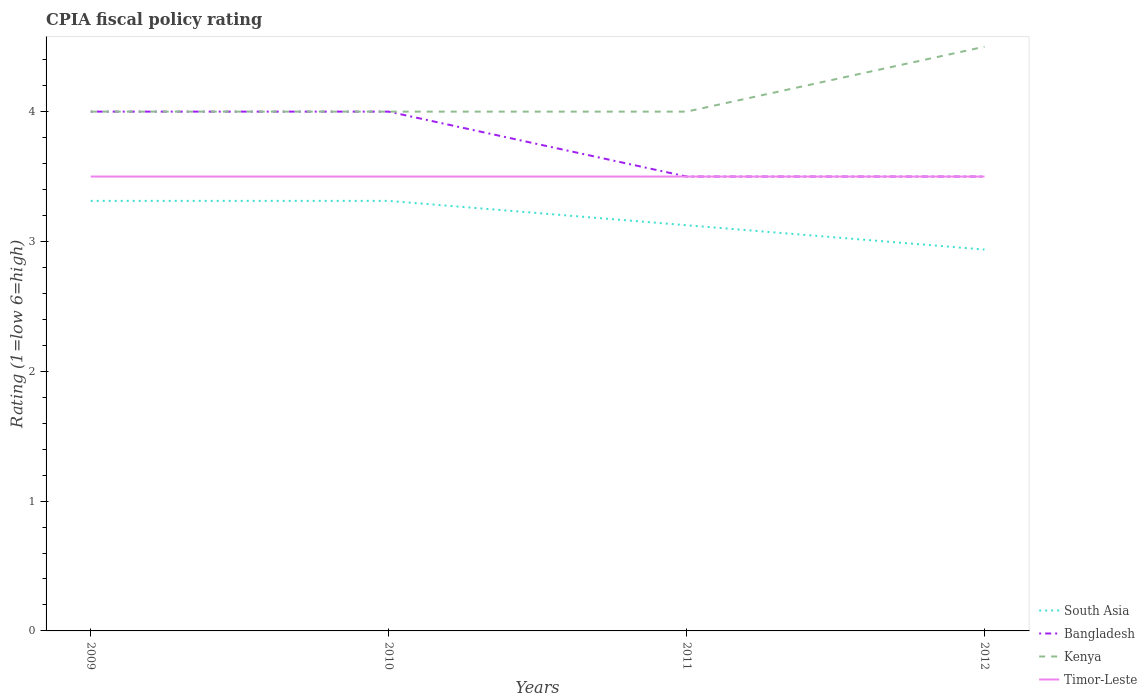Does the line corresponding to Bangladesh intersect with the line corresponding to Timor-Leste?
Provide a succinct answer. Yes. Across all years, what is the maximum CPIA rating in Bangladesh?
Offer a terse response. 3.5. What is the difference between the highest and the second highest CPIA rating in Timor-Leste?
Your response must be concise. 0. What is the difference between the highest and the lowest CPIA rating in Kenya?
Offer a very short reply. 1. What is the difference between two consecutive major ticks on the Y-axis?
Offer a very short reply. 1. Are the values on the major ticks of Y-axis written in scientific E-notation?
Provide a short and direct response. No. Does the graph contain grids?
Your response must be concise. No. How many legend labels are there?
Your answer should be very brief. 4. What is the title of the graph?
Provide a short and direct response. CPIA fiscal policy rating. What is the label or title of the X-axis?
Your answer should be very brief. Years. What is the label or title of the Y-axis?
Keep it short and to the point. Rating (1=low 6=high). What is the Rating (1=low 6=high) of South Asia in 2009?
Keep it short and to the point. 3.31. What is the Rating (1=low 6=high) of Bangladesh in 2009?
Keep it short and to the point. 4. What is the Rating (1=low 6=high) in South Asia in 2010?
Provide a short and direct response. 3.31. What is the Rating (1=low 6=high) of South Asia in 2011?
Provide a short and direct response. 3.12. What is the Rating (1=low 6=high) of Kenya in 2011?
Provide a short and direct response. 4. What is the Rating (1=low 6=high) in South Asia in 2012?
Make the answer very short. 2.94. What is the Rating (1=low 6=high) of Timor-Leste in 2012?
Provide a short and direct response. 3.5. Across all years, what is the maximum Rating (1=low 6=high) in South Asia?
Offer a terse response. 3.31. Across all years, what is the maximum Rating (1=low 6=high) of Bangladesh?
Keep it short and to the point. 4. Across all years, what is the maximum Rating (1=low 6=high) of Kenya?
Your answer should be very brief. 4.5. Across all years, what is the minimum Rating (1=low 6=high) of South Asia?
Keep it short and to the point. 2.94. Across all years, what is the minimum Rating (1=low 6=high) in Kenya?
Offer a terse response. 4. What is the total Rating (1=low 6=high) in South Asia in the graph?
Keep it short and to the point. 12.69. What is the total Rating (1=low 6=high) of Bangladesh in the graph?
Make the answer very short. 15. What is the total Rating (1=low 6=high) in Kenya in the graph?
Give a very brief answer. 16.5. What is the total Rating (1=low 6=high) of Timor-Leste in the graph?
Offer a very short reply. 14. What is the difference between the Rating (1=low 6=high) of South Asia in 2009 and that in 2010?
Provide a succinct answer. 0. What is the difference between the Rating (1=low 6=high) in Timor-Leste in 2009 and that in 2010?
Offer a terse response. 0. What is the difference between the Rating (1=low 6=high) of South Asia in 2009 and that in 2011?
Your response must be concise. 0.19. What is the difference between the Rating (1=low 6=high) of Timor-Leste in 2009 and that in 2011?
Give a very brief answer. 0. What is the difference between the Rating (1=low 6=high) of Kenya in 2009 and that in 2012?
Your response must be concise. -0.5. What is the difference between the Rating (1=low 6=high) in Timor-Leste in 2009 and that in 2012?
Your response must be concise. 0. What is the difference between the Rating (1=low 6=high) in South Asia in 2010 and that in 2011?
Your answer should be compact. 0.19. What is the difference between the Rating (1=low 6=high) in Kenya in 2010 and that in 2011?
Make the answer very short. 0. What is the difference between the Rating (1=low 6=high) in Timor-Leste in 2010 and that in 2011?
Make the answer very short. 0. What is the difference between the Rating (1=low 6=high) in South Asia in 2010 and that in 2012?
Offer a terse response. 0.38. What is the difference between the Rating (1=low 6=high) in Bangladesh in 2010 and that in 2012?
Offer a very short reply. 0.5. What is the difference between the Rating (1=low 6=high) of Kenya in 2010 and that in 2012?
Offer a terse response. -0.5. What is the difference between the Rating (1=low 6=high) in South Asia in 2011 and that in 2012?
Give a very brief answer. 0.19. What is the difference between the Rating (1=low 6=high) in Kenya in 2011 and that in 2012?
Make the answer very short. -0.5. What is the difference between the Rating (1=low 6=high) of Timor-Leste in 2011 and that in 2012?
Provide a succinct answer. 0. What is the difference between the Rating (1=low 6=high) in South Asia in 2009 and the Rating (1=low 6=high) in Bangladesh in 2010?
Provide a succinct answer. -0.69. What is the difference between the Rating (1=low 6=high) in South Asia in 2009 and the Rating (1=low 6=high) in Kenya in 2010?
Ensure brevity in your answer.  -0.69. What is the difference between the Rating (1=low 6=high) in South Asia in 2009 and the Rating (1=low 6=high) in Timor-Leste in 2010?
Provide a succinct answer. -0.19. What is the difference between the Rating (1=low 6=high) in Kenya in 2009 and the Rating (1=low 6=high) in Timor-Leste in 2010?
Your answer should be very brief. 0.5. What is the difference between the Rating (1=low 6=high) in South Asia in 2009 and the Rating (1=low 6=high) in Bangladesh in 2011?
Your answer should be very brief. -0.19. What is the difference between the Rating (1=low 6=high) of South Asia in 2009 and the Rating (1=low 6=high) of Kenya in 2011?
Offer a terse response. -0.69. What is the difference between the Rating (1=low 6=high) in South Asia in 2009 and the Rating (1=low 6=high) in Timor-Leste in 2011?
Give a very brief answer. -0.19. What is the difference between the Rating (1=low 6=high) in Bangladesh in 2009 and the Rating (1=low 6=high) in Timor-Leste in 2011?
Make the answer very short. 0.5. What is the difference between the Rating (1=low 6=high) in South Asia in 2009 and the Rating (1=low 6=high) in Bangladesh in 2012?
Provide a succinct answer. -0.19. What is the difference between the Rating (1=low 6=high) in South Asia in 2009 and the Rating (1=low 6=high) in Kenya in 2012?
Ensure brevity in your answer.  -1.19. What is the difference between the Rating (1=low 6=high) in South Asia in 2009 and the Rating (1=low 6=high) in Timor-Leste in 2012?
Your answer should be compact. -0.19. What is the difference between the Rating (1=low 6=high) in Bangladesh in 2009 and the Rating (1=low 6=high) in Timor-Leste in 2012?
Make the answer very short. 0.5. What is the difference between the Rating (1=low 6=high) in Kenya in 2009 and the Rating (1=low 6=high) in Timor-Leste in 2012?
Provide a short and direct response. 0.5. What is the difference between the Rating (1=low 6=high) in South Asia in 2010 and the Rating (1=low 6=high) in Bangladesh in 2011?
Offer a terse response. -0.19. What is the difference between the Rating (1=low 6=high) in South Asia in 2010 and the Rating (1=low 6=high) in Kenya in 2011?
Your answer should be compact. -0.69. What is the difference between the Rating (1=low 6=high) in South Asia in 2010 and the Rating (1=low 6=high) in Timor-Leste in 2011?
Your answer should be very brief. -0.19. What is the difference between the Rating (1=low 6=high) of Bangladesh in 2010 and the Rating (1=low 6=high) of Kenya in 2011?
Your answer should be very brief. 0. What is the difference between the Rating (1=low 6=high) in Bangladesh in 2010 and the Rating (1=low 6=high) in Timor-Leste in 2011?
Make the answer very short. 0.5. What is the difference between the Rating (1=low 6=high) in South Asia in 2010 and the Rating (1=low 6=high) in Bangladesh in 2012?
Make the answer very short. -0.19. What is the difference between the Rating (1=low 6=high) of South Asia in 2010 and the Rating (1=low 6=high) of Kenya in 2012?
Provide a short and direct response. -1.19. What is the difference between the Rating (1=low 6=high) in South Asia in 2010 and the Rating (1=low 6=high) in Timor-Leste in 2012?
Provide a short and direct response. -0.19. What is the difference between the Rating (1=low 6=high) in South Asia in 2011 and the Rating (1=low 6=high) in Bangladesh in 2012?
Your answer should be very brief. -0.38. What is the difference between the Rating (1=low 6=high) of South Asia in 2011 and the Rating (1=low 6=high) of Kenya in 2012?
Give a very brief answer. -1.38. What is the difference between the Rating (1=low 6=high) in South Asia in 2011 and the Rating (1=low 6=high) in Timor-Leste in 2012?
Keep it short and to the point. -0.38. What is the difference between the Rating (1=low 6=high) of Bangladesh in 2011 and the Rating (1=low 6=high) of Kenya in 2012?
Ensure brevity in your answer.  -1. What is the difference between the Rating (1=low 6=high) of Kenya in 2011 and the Rating (1=low 6=high) of Timor-Leste in 2012?
Provide a short and direct response. 0.5. What is the average Rating (1=low 6=high) of South Asia per year?
Provide a short and direct response. 3.17. What is the average Rating (1=low 6=high) in Bangladesh per year?
Ensure brevity in your answer.  3.75. What is the average Rating (1=low 6=high) in Kenya per year?
Give a very brief answer. 4.12. In the year 2009, what is the difference between the Rating (1=low 6=high) of South Asia and Rating (1=low 6=high) of Bangladesh?
Give a very brief answer. -0.69. In the year 2009, what is the difference between the Rating (1=low 6=high) of South Asia and Rating (1=low 6=high) of Kenya?
Your response must be concise. -0.69. In the year 2009, what is the difference between the Rating (1=low 6=high) of South Asia and Rating (1=low 6=high) of Timor-Leste?
Make the answer very short. -0.19. In the year 2009, what is the difference between the Rating (1=low 6=high) in Bangladesh and Rating (1=low 6=high) in Timor-Leste?
Your answer should be compact. 0.5. In the year 2010, what is the difference between the Rating (1=low 6=high) in South Asia and Rating (1=low 6=high) in Bangladesh?
Your answer should be very brief. -0.69. In the year 2010, what is the difference between the Rating (1=low 6=high) of South Asia and Rating (1=low 6=high) of Kenya?
Keep it short and to the point. -0.69. In the year 2010, what is the difference between the Rating (1=low 6=high) in South Asia and Rating (1=low 6=high) in Timor-Leste?
Your answer should be very brief. -0.19. In the year 2010, what is the difference between the Rating (1=low 6=high) in Bangladesh and Rating (1=low 6=high) in Timor-Leste?
Ensure brevity in your answer.  0.5. In the year 2010, what is the difference between the Rating (1=low 6=high) in Kenya and Rating (1=low 6=high) in Timor-Leste?
Provide a short and direct response. 0.5. In the year 2011, what is the difference between the Rating (1=low 6=high) of South Asia and Rating (1=low 6=high) of Bangladesh?
Your response must be concise. -0.38. In the year 2011, what is the difference between the Rating (1=low 6=high) in South Asia and Rating (1=low 6=high) in Kenya?
Your answer should be very brief. -0.88. In the year 2011, what is the difference between the Rating (1=low 6=high) in South Asia and Rating (1=low 6=high) in Timor-Leste?
Provide a succinct answer. -0.38. In the year 2011, what is the difference between the Rating (1=low 6=high) of Bangladesh and Rating (1=low 6=high) of Kenya?
Your answer should be compact. -0.5. In the year 2011, what is the difference between the Rating (1=low 6=high) in Bangladesh and Rating (1=low 6=high) in Timor-Leste?
Your answer should be very brief. 0. In the year 2012, what is the difference between the Rating (1=low 6=high) of South Asia and Rating (1=low 6=high) of Bangladesh?
Offer a very short reply. -0.56. In the year 2012, what is the difference between the Rating (1=low 6=high) of South Asia and Rating (1=low 6=high) of Kenya?
Ensure brevity in your answer.  -1.56. In the year 2012, what is the difference between the Rating (1=low 6=high) in South Asia and Rating (1=low 6=high) in Timor-Leste?
Ensure brevity in your answer.  -0.56. In the year 2012, what is the difference between the Rating (1=low 6=high) in Bangladesh and Rating (1=low 6=high) in Kenya?
Give a very brief answer. -1. In the year 2012, what is the difference between the Rating (1=low 6=high) in Bangladesh and Rating (1=low 6=high) in Timor-Leste?
Provide a succinct answer. 0. In the year 2012, what is the difference between the Rating (1=low 6=high) in Kenya and Rating (1=low 6=high) in Timor-Leste?
Your response must be concise. 1. What is the ratio of the Rating (1=low 6=high) of Bangladesh in 2009 to that in 2010?
Keep it short and to the point. 1. What is the ratio of the Rating (1=low 6=high) in Kenya in 2009 to that in 2010?
Your response must be concise. 1. What is the ratio of the Rating (1=low 6=high) of Timor-Leste in 2009 to that in 2010?
Provide a short and direct response. 1. What is the ratio of the Rating (1=low 6=high) in South Asia in 2009 to that in 2011?
Ensure brevity in your answer.  1.06. What is the ratio of the Rating (1=low 6=high) in Bangladesh in 2009 to that in 2011?
Provide a succinct answer. 1.14. What is the ratio of the Rating (1=low 6=high) of Timor-Leste in 2009 to that in 2011?
Your response must be concise. 1. What is the ratio of the Rating (1=low 6=high) in South Asia in 2009 to that in 2012?
Provide a short and direct response. 1.13. What is the ratio of the Rating (1=low 6=high) of Bangladesh in 2009 to that in 2012?
Offer a terse response. 1.14. What is the ratio of the Rating (1=low 6=high) of Kenya in 2009 to that in 2012?
Your answer should be very brief. 0.89. What is the ratio of the Rating (1=low 6=high) of South Asia in 2010 to that in 2011?
Your answer should be compact. 1.06. What is the ratio of the Rating (1=low 6=high) in Bangladesh in 2010 to that in 2011?
Provide a succinct answer. 1.14. What is the ratio of the Rating (1=low 6=high) in Kenya in 2010 to that in 2011?
Your answer should be very brief. 1. What is the ratio of the Rating (1=low 6=high) of Timor-Leste in 2010 to that in 2011?
Make the answer very short. 1. What is the ratio of the Rating (1=low 6=high) of South Asia in 2010 to that in 2012?
Offer a terse response. 1.13. What is the ratio of the Rating (1=low 6=high) in Bangladesh in 2010 to that in 2012?
Provide a succinct answer. 1.14. What is the ratio of the Rating (1=low 6=high) in Kenya in 2010 to that in 2012?
Keep it short and to the point. 0.89. What is the ratio of the Rating (1=low 6=high) in South Asia in 2011 to that in 2012?
Keep it short and to the point. 1.06. What is the ratio of the Rating (1=low 6=high) of Bangladesh in 2011 to that in 2012?
Offer a terse response. 1. What is the ratio of the Rating (1=low 6=high) in Kenya in 2011 to that in 2012?
Give a very brief answer. 0.89. What is the ratio of the Rating (1=low 6=high) of Timor-Leste in 2011 to that in 2012?
Keep it short and to the point. 1. What is the difference between the highest and the second highest Rating (1=low 6=high) in South Asia?
Your answer should be very brief. 0. What is the difference between the highest and the second highest Rating (1=low 6=high) in Bangladesh?
Your response must be concise. 0. What is the difference between the highest and the second highest Rating (1=low 6=high) in Kenya?
Your answer should be very brief. 0.5. What is the difference between the highest and the second highest Rating (1=low 6=high) of Timor-Leste?
Your response must be concise. 0. 